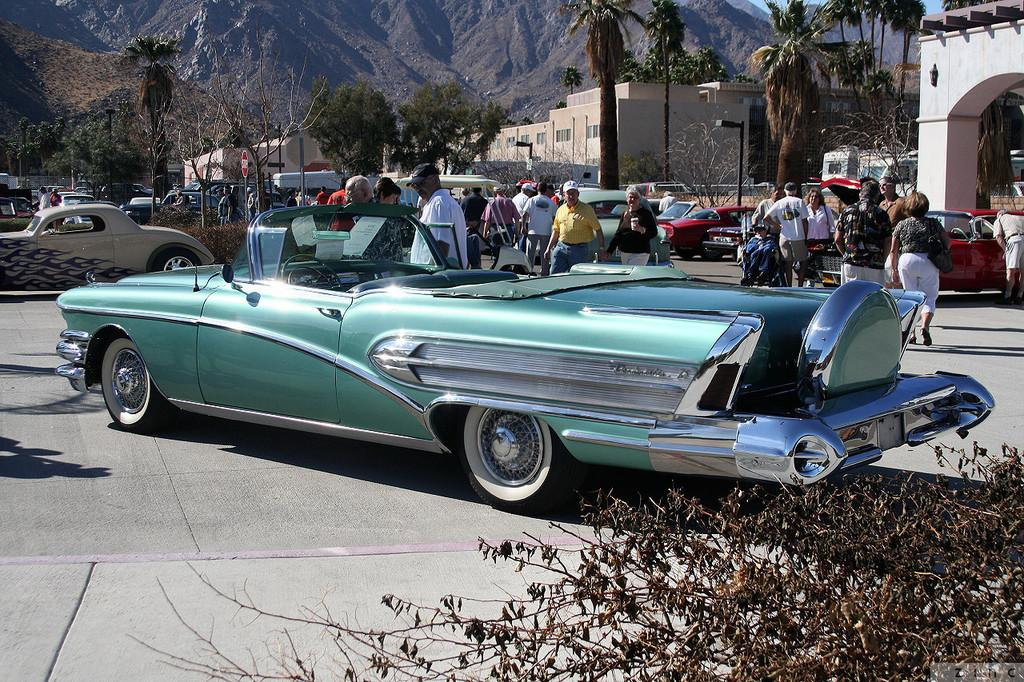What are the people in the image doing? The people in the image are walking on the road. What else can be seen in the image besides people? There are vehicles visible in the image. What can be seen in the background of the image? There are buildings, trees, and mountains visible in the background. What type of stew is being served in the image? There is no stew present in the image. What color is the collar of the dog in the image? There is no dog, and therefore no collar, present in the image. 